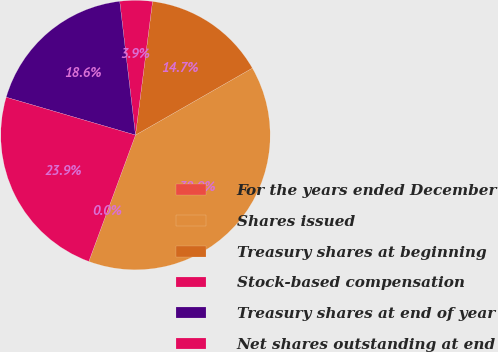<chart> <loc_0><loc_0><loc_500><loc_500><pie_chart><fcel>For the years ended December<fcel>Shares issued<fcel>Treasury shares at beginning<fcel>Stock-based compensation<fcel>Treasury shares at end of year<fcel>Net shares outstanding at end<nl><fcel>0.0%<fcel>38.91%<fcel>14.7%<fcel>3.89%<fcel>18.6%<fcel>23.9%<nl></chart> 